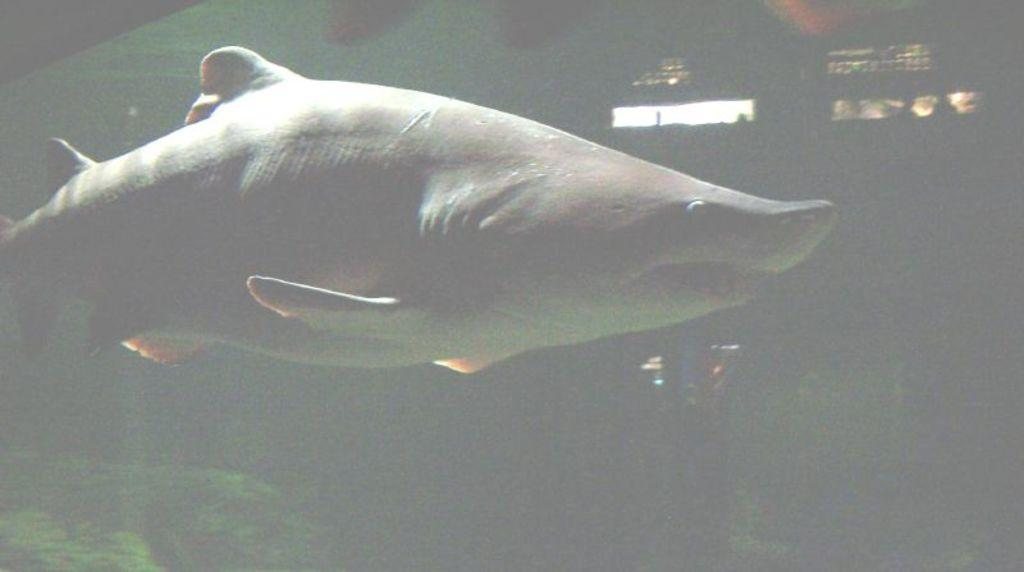What type of animals can be seen in the image? There are fish in the image. What is the color of the background in the image? The background of the image is dark. What expert advice can be seen in the aftermath of the rule change in the image? There is no expert advice or rule change present in the image; it features fish and a dark background. 